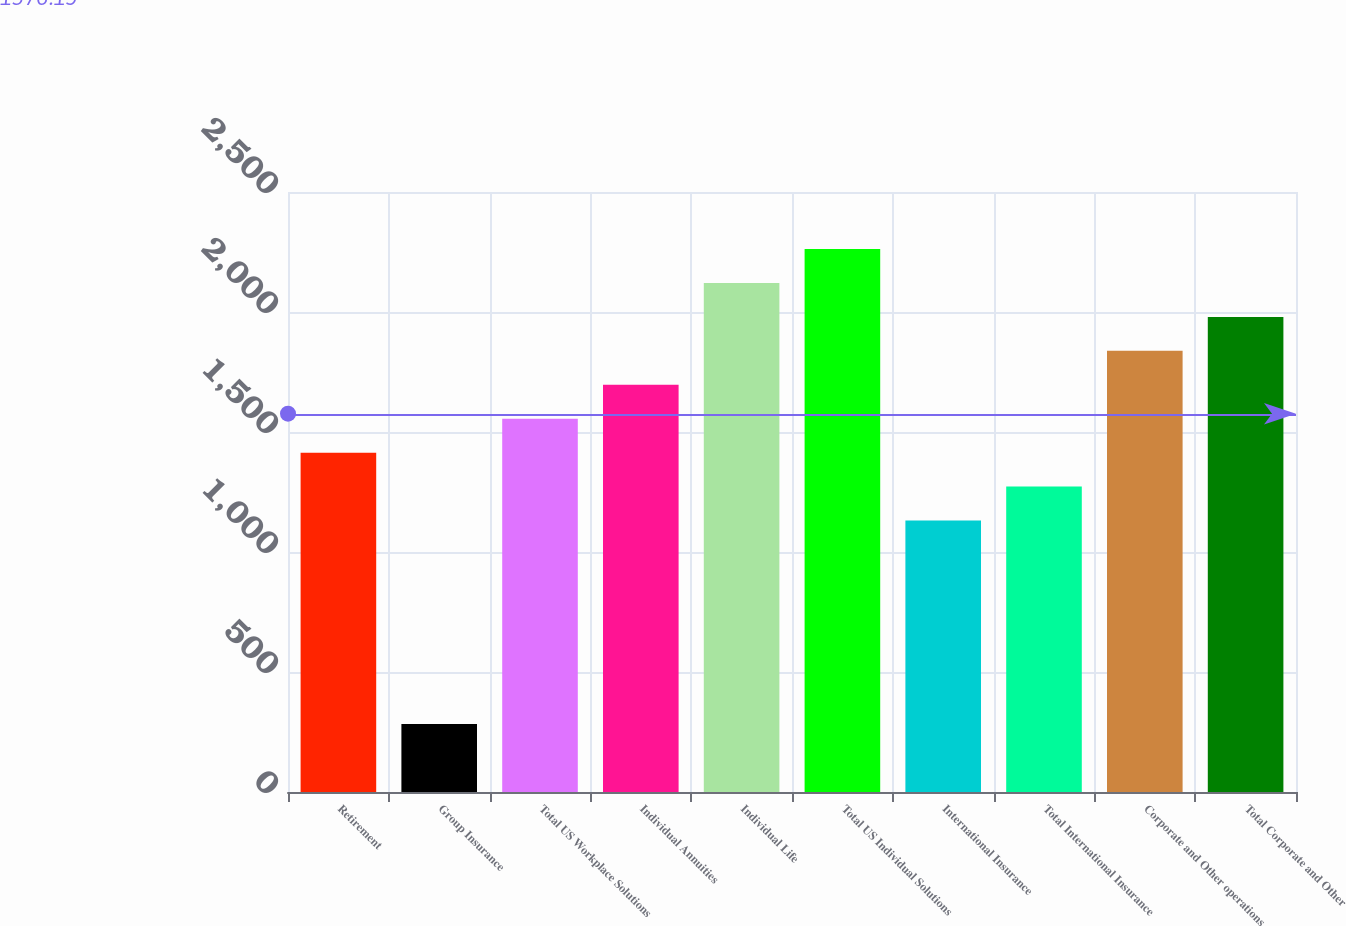Convert chart to OTSL. <chart><loc_0><loc_0><loc_500><loc_500><bar_chart><fcel>Retirement<fcel>Group Insurance<fcel>Total US Workplace Solutions<fcel>Individual Annuities<fcel>Individual Life<fcel>Total US Individual Solutions<fcel>International Insurance<fcel>Total International Insurance<fcel>Corporate and Other operations<fcel>Total Corporate and Other<nl><fcel>1414.03<fcel>283.25<fcel>1555.38<fcel>1696.73<fcel>2120.76<fcel>2262.11<fcel>1131.34<fcel>1272.68<fcel>1838.08<fcel>1979.42<nl></chart> 